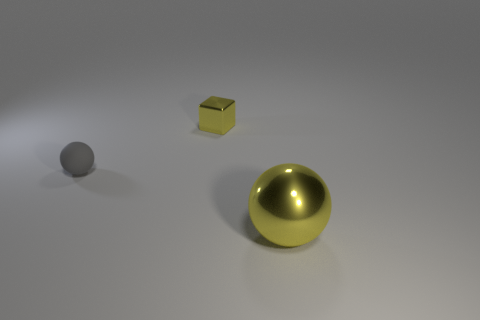What is the size of the shiny ball that is the same color as the metallic cube?
Your answer should be compact. Large. There is a object that is the same material as the yellow block; what size is it?
Offer a terse response. Large. There is a object that is behind the rubber ball; is it the same size as the large yellow shiny sphere?
Ensure brevity in your answer.  No. There is a tiny gray rubber thing behind the shiny object in front of the shiny thing that is behind the gray sphere; what is its shape?
Your answer should be very brief. Sphere. How many objects are small shiny blocks or yellow metallic things that are left of the big yellow shiny object?
Make the answer very short. 1. There is a yellow metallic object that is to the right of the cube; what size is it?
Ensure brevity in your answer.  Large. There is a small metallic object that is the same color as the big ball; what is its shape?
Provide a succinct answer. Cube. Is the small block made of the same material as the sphere left of the big yellow ball?
Keep it short and to the point. No. What number of tiny things are left of the sphere that is to the left of the thing in front of the gray rubber sphere?
Provide a short and direct response. 0. What number of yellow objects are either big matte cylinders or tiny matte spheres?
Make the answer very short. 0. 